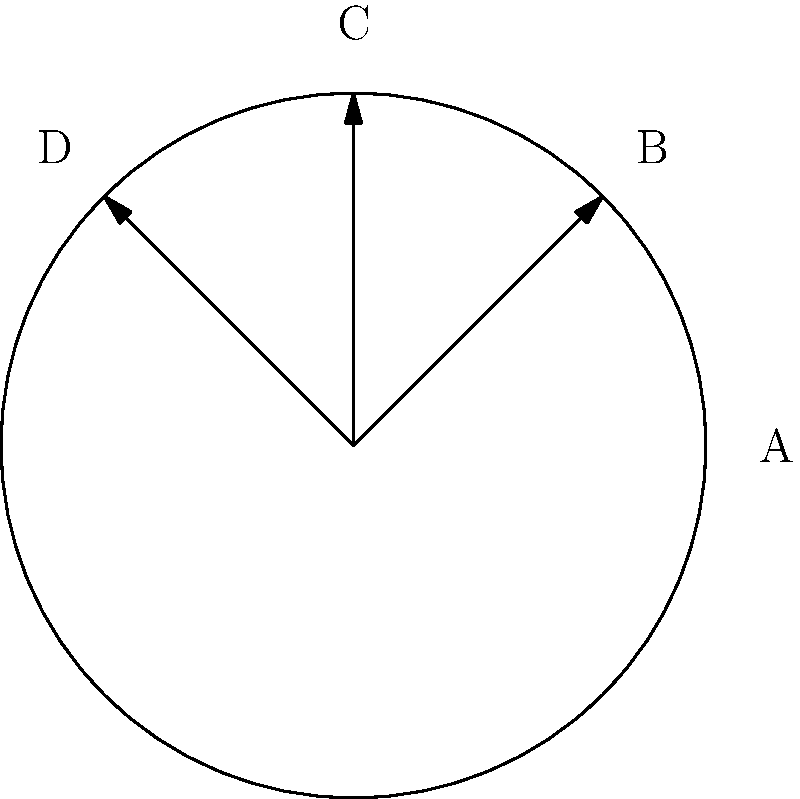In the diagram above, four soccer balls are shown with different rotations. If ball A is rotated 135° counterclockwise, which ball would it most closely resemble? To solve this problem, we need to follow these steps:

1. Understand the given information:
   - Ball A is the reference ball (not rotated).
   - We need to rotate Ball A by 135° counterclockwise.

2. Analyze the rotation of the other balls:
   - Ball B is rotated 45° counterclockwise from A.
   - Ball C is rotated 90° counterclockwise from A.
   - Ball D is rotated 135° counterclockwise from A.

3. Compare the required rotation (135° counterclockwise) with the given options:
   - 135° is exactly the rotation applied to Ball D.

4. Conclude that after rotating Ball A by 135° counterclockwise, it would look identical to Ball D.
Answer: D 